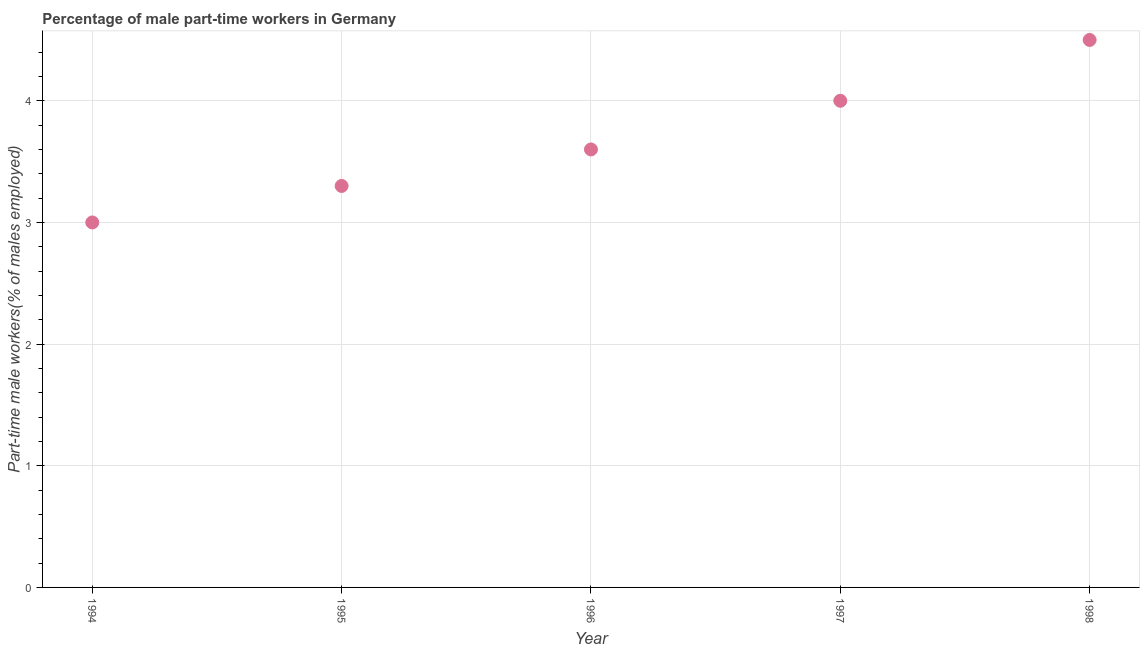Across all years, what is the maximum percentage of part-time male workers?
Your answer should be compact. 4.5. Across all years, what is the minimum percentage of part-time male workers?
Ensure brevity in your answer.  3. In which year was the percentage of part-time male workers minimum?
Provide a short and direct response. 1994. What is the sum of the percentage of part-time male workers?
Give a very brief answer. 18.4. What is the difference between the percentage of part-time male workers in 1994 and 1995?
Keep it short and to the point. -0.3. What is the average percentage of part-time male workers per year?
Offer a very short reply. 3.68. What is the median percentage of part-time male workers?
Provide a succinct answer. 3.6. What is the ratio of the percentage of part-time male workers in 1996 to that in 1998?
Make the answer very short. 0.8. Is the percentage of part-time male workers in 1995 less than that in 1998?
Ensure brevity in your answer.  Yes. What is the difference between the highest and the second highest percentage of part-time male workers?
Offer a very short reply. 0.5. Is the sum of the percentage of part-time male workers in 1996 and 1998 greater than the maximum percentage of part-time male workers across all years?
Give a very brief answer. Yes. In how many years, is the percentage of part-time male workers greater than the average percentage of part-time male workers taken over all years?
Offer a terse response. 2. How many dotlines are there?
Provide a succinct answer. 1. Are the values on the major ticks of Y-axis written in scientific E-notation?
Provide a succinct answer. No. Does the graph contain any zero values?
Offer a very short reply. No. What is the title of the graph?
Your answer should be compact. Percentage of male part-time workers in Germany. What is the label or title of the Y-axis?
Make the answer very short. Part-time male workers(% of males employed). What is the Part-time male workers(% of males employed) in 1995?
Offer a terse response. 3.3. What is the Part-time male workers(% of males employed) in 1996?
Ensure brevity in your answer.  3.6. What is the Part-time male workers(% of males employed) in 1997?
Your answer should be compact. 4. What is the Part-time male workers(% of males employed) in 1998?
Provide a short and direct response. 4.5. What is the difference between the Part-time male workers(% of males employed) in 1994 and 1995?
Keep it short and to the point. -0.3. What is the difference between the Part-time male workers(% of males employed) in 1994 and 1997?
Provide a succinct answer. -1. What is the difference between the Part-time male workers(% of males employed) in 1995 and 1997?
Offer a terse response. -0.7. What is the difference between the Part-time male workers(% of males employed) in 1995 and 1998?
Give a very brief answer. -1.2. What is the difference between the Part-time male workers(% of males employed) in 1996 and 1998?
Your answer should be very brief. -0.9. What is the difference between the Part-time male workers(% of males employed) in 1997 and 1998?
Keep it short and to the point. -0.5. What is the ratio of the Part-time male workers(% of males employed) in 1994 to that in 1995?
Offer a terse response. 0.91. What is the ratio of the Part-time male workers(% of males employed) in 1994 to that in 1996?
Provide a succinct answer. 0.83. What is the ratio of the Part-time male workers(% of males employed) in 1994 to that in 1998?
Your answer should be very brief. 0.67. What is the ratio of the Part-time male workers(% of males employed) in 1995 to that in 1996?
Offer a very short reply. 0.92. What is the ratio of the Part-time male workers(% of males employed) in 1995 to that in 1997?
Make the answer very short. 0.82. What is the ratio of the Part-time male workers(% of males employed) in 1995 to that in 1998?
Provide a short and direct response. 0.73. What is the ratio of the Part-time male workers(% of males employed) in 1996 to that in 1997?
Your answer should be very brief. 0.9. What is the ratio of the Part-time male workers(% of males employed) in 1996 to that in 1998?
Make the answer very short. 0.8. What is the ratio of the Part-time male workers(% of males employed) in 1997 to that in 1998?
Make the answer very short. 0.89. 